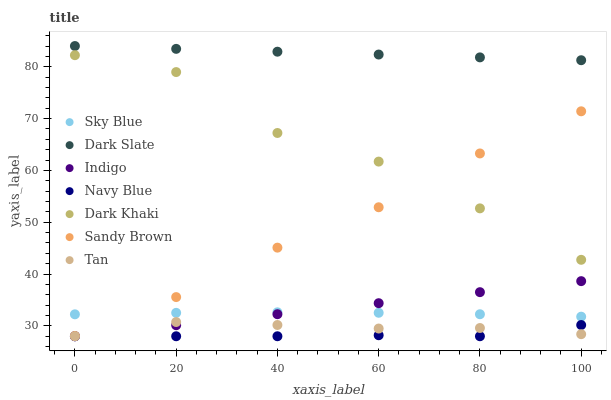Does Navy Blue have the minimum area under the curve?
Answer yes or no. Yes. Does Dark Slate have the maximum area under the curve?
Answer yes or no. Yes. Does Dark Khaki have the minimum area under the curve?
Answer yes or no. No. Does Dark Khaki have the maximum area under the curve?
Answer yes or no. No. Is Indigo the smoothest?
Answer yes or no. Yes. Is Dark Khaki the roughest?
Answer yes or no. Yes. Is Navy Blue the smoothest?
Answer yes or no. No. Is Navy Blue the roughest?
Answer yes or no. No. Does Indigo have the lowest value?
Answer yes or no. Yes. Does Dark Khaki have the lowest value?
Answer yes or no. No. Does Dark Slate have the highest value?
Answer yes or no. Yes. Does Dark Khaki have the highest value?
Answer yes or no. No. Is Dark Khaki less than Dark Slate?
Answer yes or no. Yes. Is Dark Slate greater than Navy Blue?
Answer yes or no. Yes. Does Indigo intersect Tan?
Answer yes or no. Yes. Is Indigo less than Tan?
Answer yes or no. No. Is Indigo greater than Tan?
Answer yes or no. No. Does Dark Khaki intersect Dark Slate?
Answer yes or no. No. 